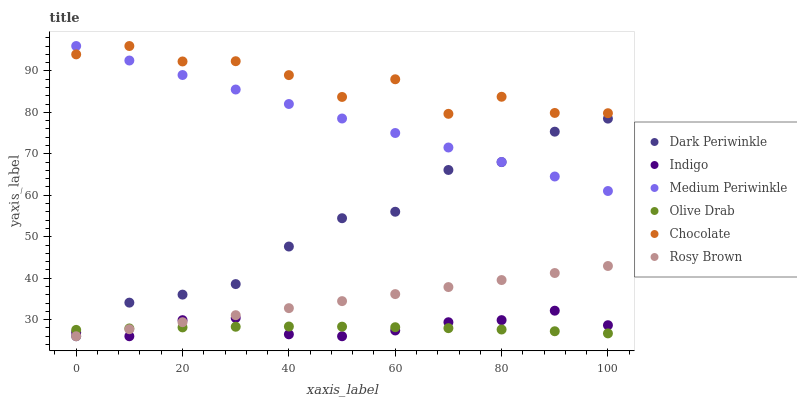Does Olive Drab have the minimum area under the curve?
Answer yes or no. Yes. Does Chocolate have the maximum area under the curve?
Answer yes or no. Yes. Does Rosy Brown have the minimum area under the curve?
Answer yes or no. No. Does Rosy Brown have the maximum area under the curve?
Answer yes or no. No. Is Medium Periwinkle the smoothest?
Answer yes or no. Yes. Is Chocolate the roughest?
Answer yes or no. Yes. Is Rosy Brown the smoothest?
Answer yes or no. No. Is Rosy Brown the roughest?
Answer yes or no. No. Does Indigo have the lowest value?
Answer yes or no. Yes. Does Medium Periwinkle have the lowest value?
Answer yes or no. No. Does Chocolate have the highest value?
Answer yes or no. Yes. Does Rosy Brown have the highest value?
Answer yes or no. No. Is Olive Drab less than Medium Periwinkle?
Answer yes or no. Yes. Is Chocolate greater than Rosy Brown?
Answer yes or no. Yes. Does Dark Periwinkle intersect Medium Periwinkle?
Answer yes or no. Yes. Is Dark Periwinkle less than Medium Periwinkle?
Answer yes or no. No. Is Dark Periwinkle greater than Medium Periwinkle?
Answer yes or no. No. Does Olive Drab intersect Medium Periwinkle?
Answer yes or no. No. 